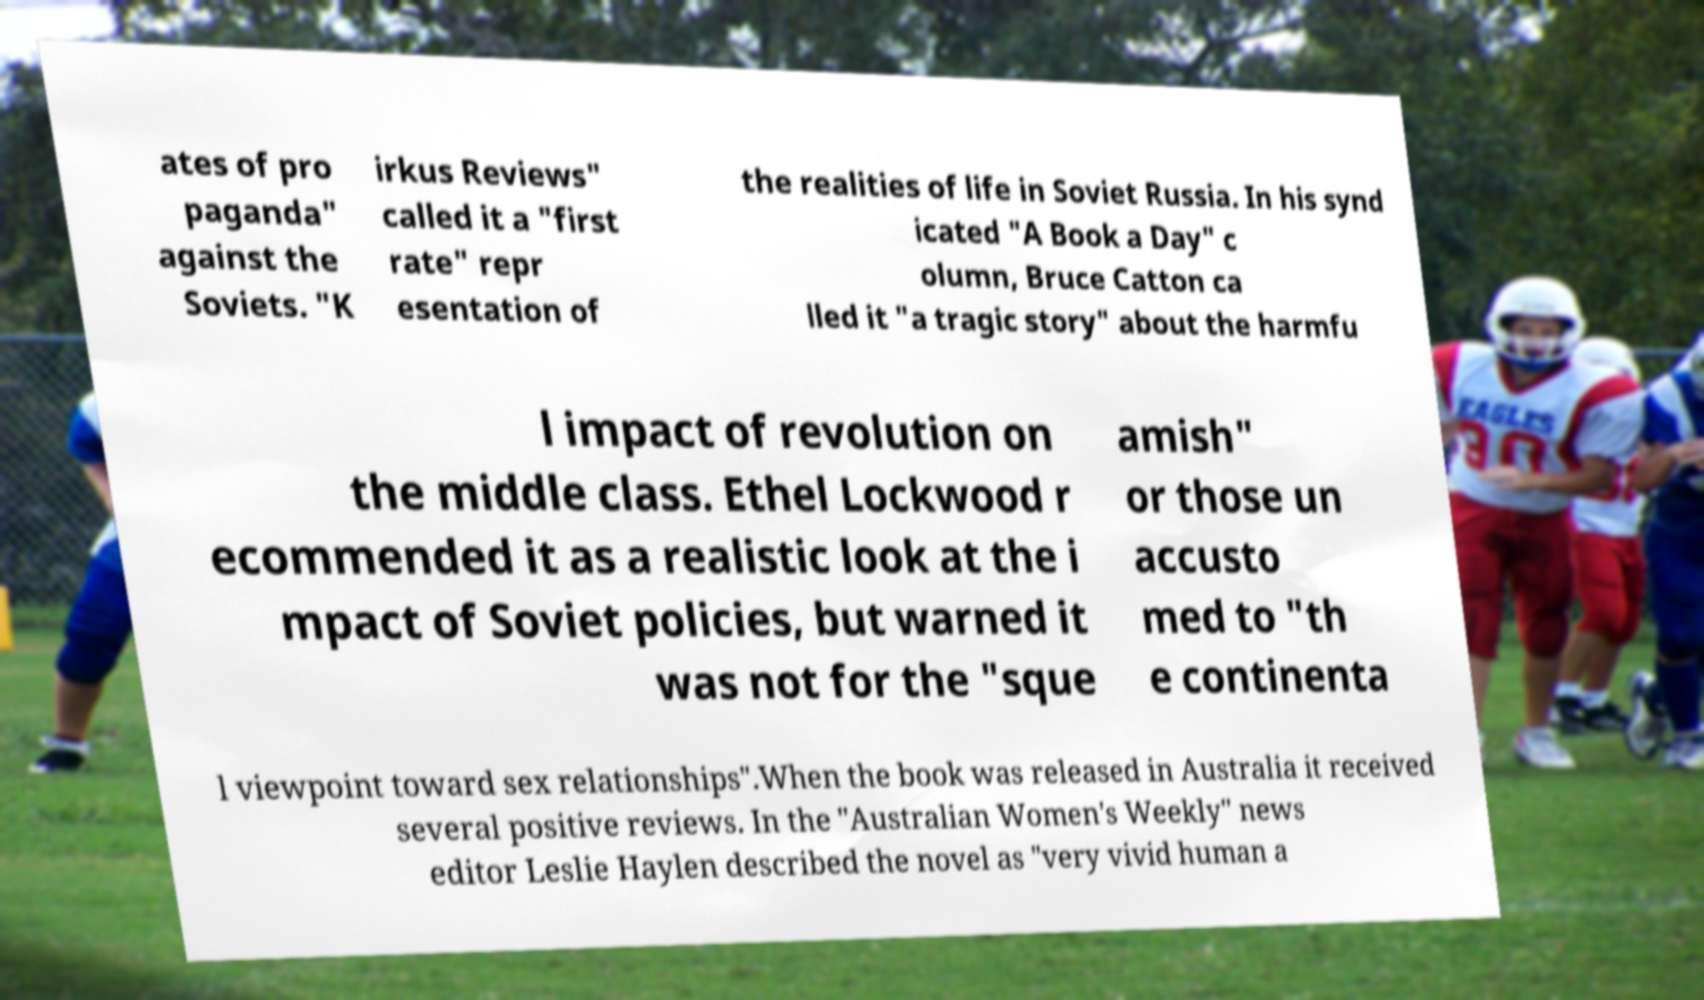Please identify and transcribe the text found in this image. ates of pro paganda" against the Soviets. "K irkus Reviews" called it a "first rate" repr esentation of the realities of life in Soviet Russia. In his synd icated "A Book a Day" c olumn, Bruce Catton ca lled it "a tragic story" about the harmfu l impact of revolution on the middle class. Ethel Lockwood r ecommended it as a realistic look at the i mpact of Soviet policies, but warned it was not for the "sque amish" or those un accusto med to "th e continenta l viewpoint toward sex relationships".When the book was released in Australia it received several positive reviews. In the "Australian Women's Weekly" news editor Leslie Haylen described the novel as "very vivid human a 